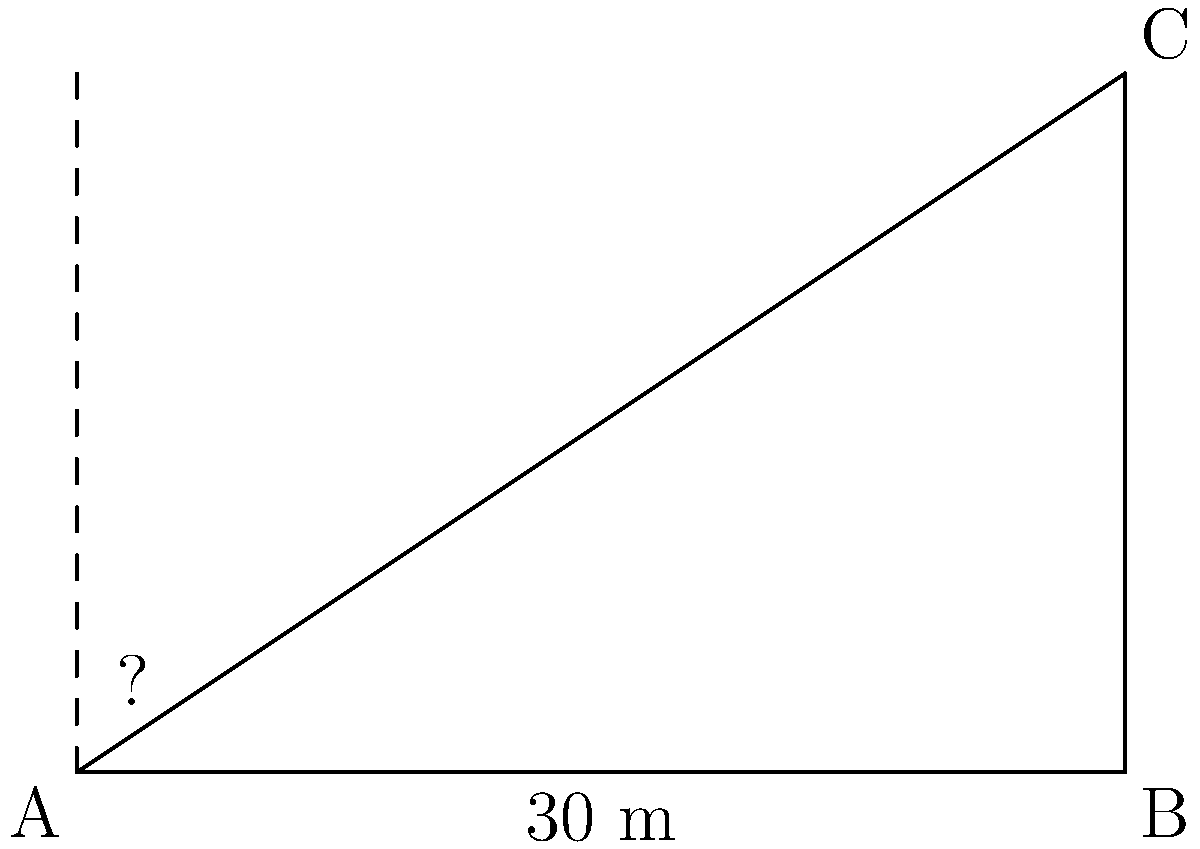A data scientist is analyzing the height of a building using trigonometric ratios. From a point on the ground, the angle of elevation to the top of a 30-meter tall building is observed. If the distance from the observer to the base of the building is also 30 meters, what is the angle of elevation in degrees? Let's approach this step-by-step using trigonometric ratios:

1) We have a right-angled triangle where:
   - The adjacent side (distance to the building) is 30 meters
   - The opposite side (height of the building) is 30 meters
   - We need to find the angle of elevation

2) In this case, we can use the tangent ratio, as we know the opposite and adjacent sides:

   $$ \tan(\theta) = \frac{\text{opposite}}{\text{adjacent}} $$

3) Substituting our known values:

   $$ \tan(\theta) = \frac{30}{30} = 1 $$

4) To find the angle $\theta$, we need to use the inverse tangent (arctan or $\tan^{-1}$):

   $$ \theta = \tan^{-1}(1) $$

5) Using a calculator or mathematical tables:

   $$ \theta \approx 45^\circ $$

This result makes sense geometrically, as a right-angled triangle with two equal sides (forming a 45-45-90 triangle) will have a 45° angle opposite the equal sides.
Answer: 45° 